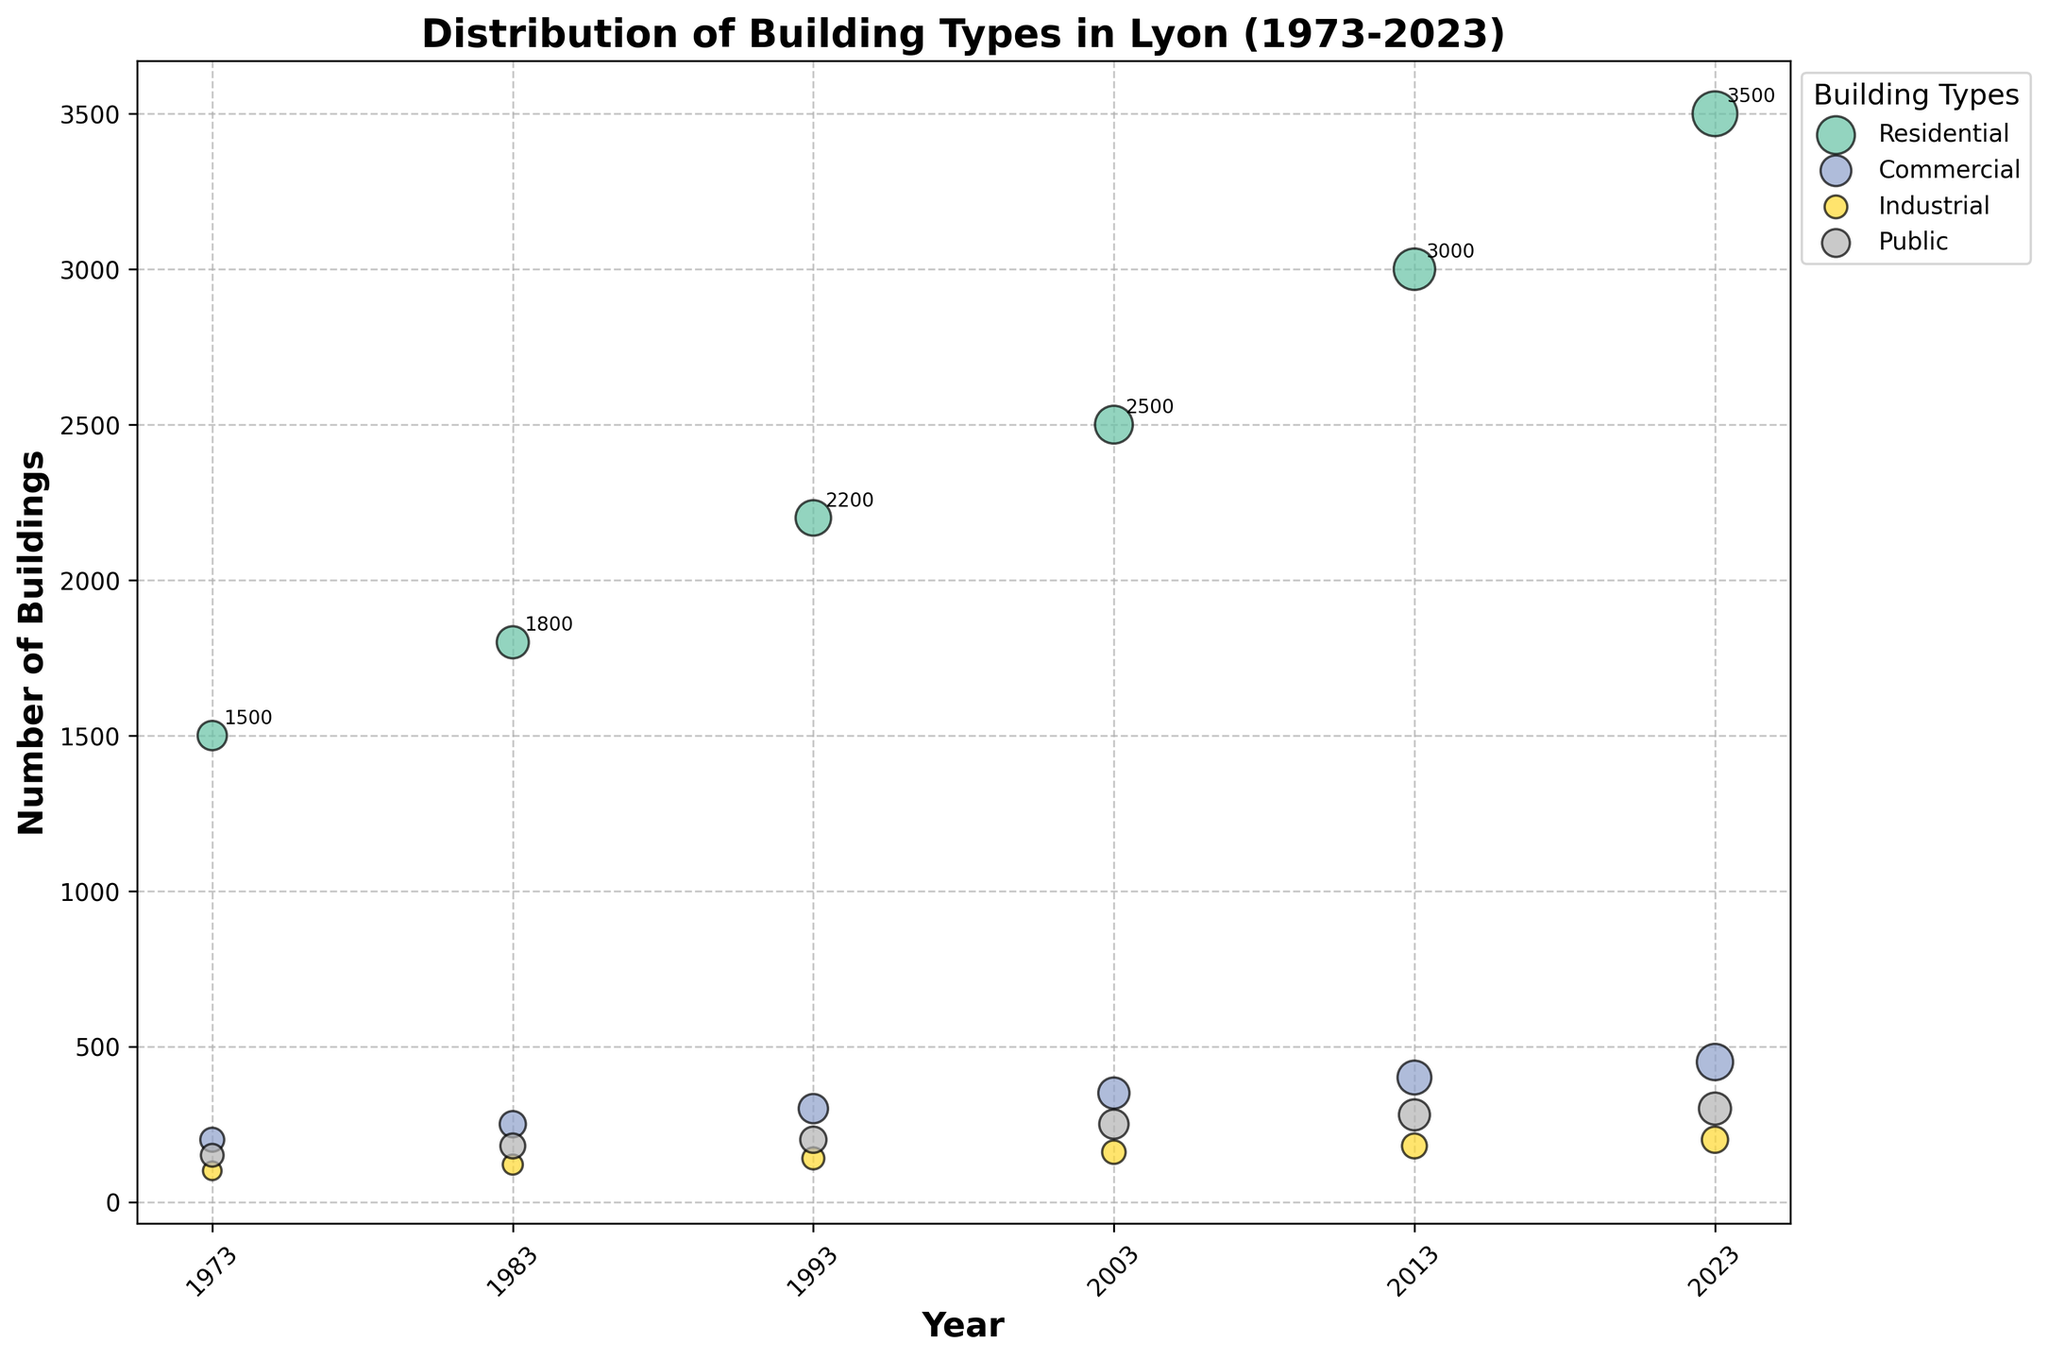What is the title of the figure? The title is usually prominently displayed at the top of the figure. In this case, based on the code provided, the title is "Distribution of Building Types in Lyon (1973-2023)".
Answer: Distribution of Building Types in Lyon (1973-2023) What do the colors in the bubbles represent? The colors in the bubbles correspond to different building types. Each building type (Residential, Commercial, Industrial, Public) is assigned a unique color.
Answer: Different building types What do the size of the bubbles indicate? The size of each bubble represents the total area in square meters for each building type and year. Larger bubbles indicate a greater total area.
Answer: Total area in square meters Which building type had the highest number of buildings in 2023? By examining the bubbles for the year 2023, the largest bubble (representing the highest number of buildings) belongs to the Residential building type.
Answer: Residential How many different building types are displayed on the figure? The figure shows different building types, each represented by different colors. By counting the unique building types, we see there are four: Residential, Commercial, Industrial, and Public.
Answer: Four Which building type had the smallest total area in the year 1973? By looking at the size of the bubbles for the year 1973, the smallest bubble belongs to the Industrial building type, indicating it had the smallest total area.
Answer: Industrial How does the number of residential buildings change from 1973 to 2023? By observing the bubble sizes and labels for Residential buildings from 1973 to 2023, there is a steady increase in the number of residential buildings from 1500 in 1973 to 3500 in 2023.
Answer: Increases from 1500 to 3500 What is the average number of Commercial buildings over the years presented? To find the average, sum the number of Commercial buildings over all years and divide by the number of years: (200 + 250 + 300 + 350 + 400 + 450) / 6 = 1950 / 6 = 325.
Answer: 325 Which year had the greatest diversity in building types in terms of the total area covered? The year with the most evenly sized bubbles (indicating relatively similar total areas across building types) appears to be 1973, as the bubble sizes are more similar compared to other years.
Answer: 1973 Compare the total area of Industrial buildings in 1983 and 2023. Which year had more area, and by how much? The total area of Industrial buildings is 350,000 sqm in 1983 and 600,000 sqm in 2023. The difference is 600,000 - 350,000 = 250,000 sqm, so 2023 had more area by 250,000 sqm.
Answer: 2023 by 250,000 sqm 